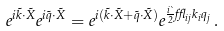<formula> <loc_0><loc_0><loc_500><loc_500>e ^ { i \vec { k } \cdot \vec { X } } e ^ { i \vec { q } \cdot \vec { X } } = e ^ { i ( \vec { k } \cdot \vec { X } + \vec { q } \cdot \vec { X } ) } e ^ { \frac { i \theta } { 2 } \epsilon _ { i j } k _ { i } q _ { j } } \, .</formula> 